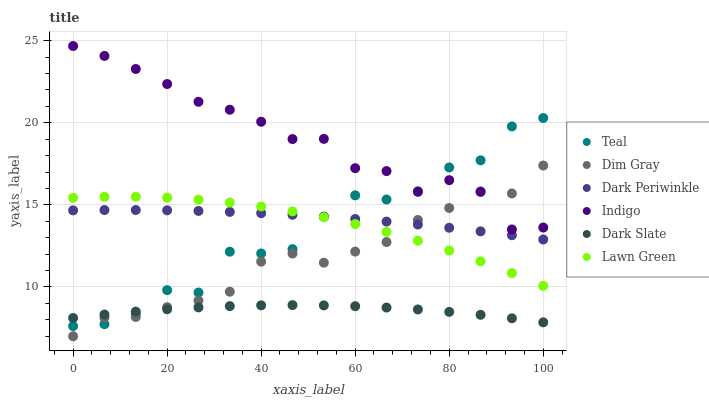Does Dark Slate have the minimum area under the curve?
Answer yes or no. Yes. Does Indigo have the maximum area under the curve?
Answer yes or no. Yes. Does Dim Gray have the minimum area under the curve?
Answer yes or no. No. Does Dim Gray have the maximum area under the curve?
Answer yes or no. No. Is Dark Periwinkle the smoothest?
Answer yes or no. Yes. Is Teal the roughest?
Answer yes or no. Yes. Is Dim Gray the smoothest?
Answer yes or no. No. Is Dim Gray the roughest?
Answer yes or no. No. Does Dim Gray have the lowest value?
Answer yes or no. Yes. Does Indigo have the lowest value?
Answer yes or no. No. Does Indigo have the highest value?
Answer yes or no. Yes. Does Dim Gray have the highest value?
Answer yes or no. No. Is Dark Slate less than Lawn Green?
Answer yes or no. Yes. Is Indigo greater than Lawn Green?
Answer yes or no. Yes. Does Dark Slate intersect Dim Gray?
Answer yes or no. Yes. Is Dark Slate less than Dim Gray?
Answer yes or no. No. Is Dark Slate greater than Dim Gray?
Answer yes or no. No. Does Dark Slate intersect Lawn Green?
Answer yes or no. No. 